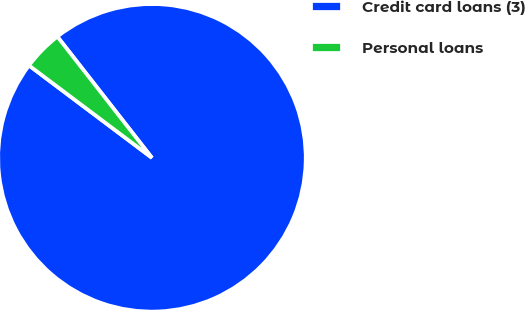Convert chart to OTSL. <chart><loc_0><loc_0><loc_500><loc_500><pie_chart><fcel>Credit card loans (3)<fcel>Personal loans<nl><fcel>95.8%<fcel>4.2%<nl></chart> 